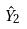<formula> <loc_0><loc_0><loc_500><loc_500>\hat { Y } _ { 2 }</formula> 